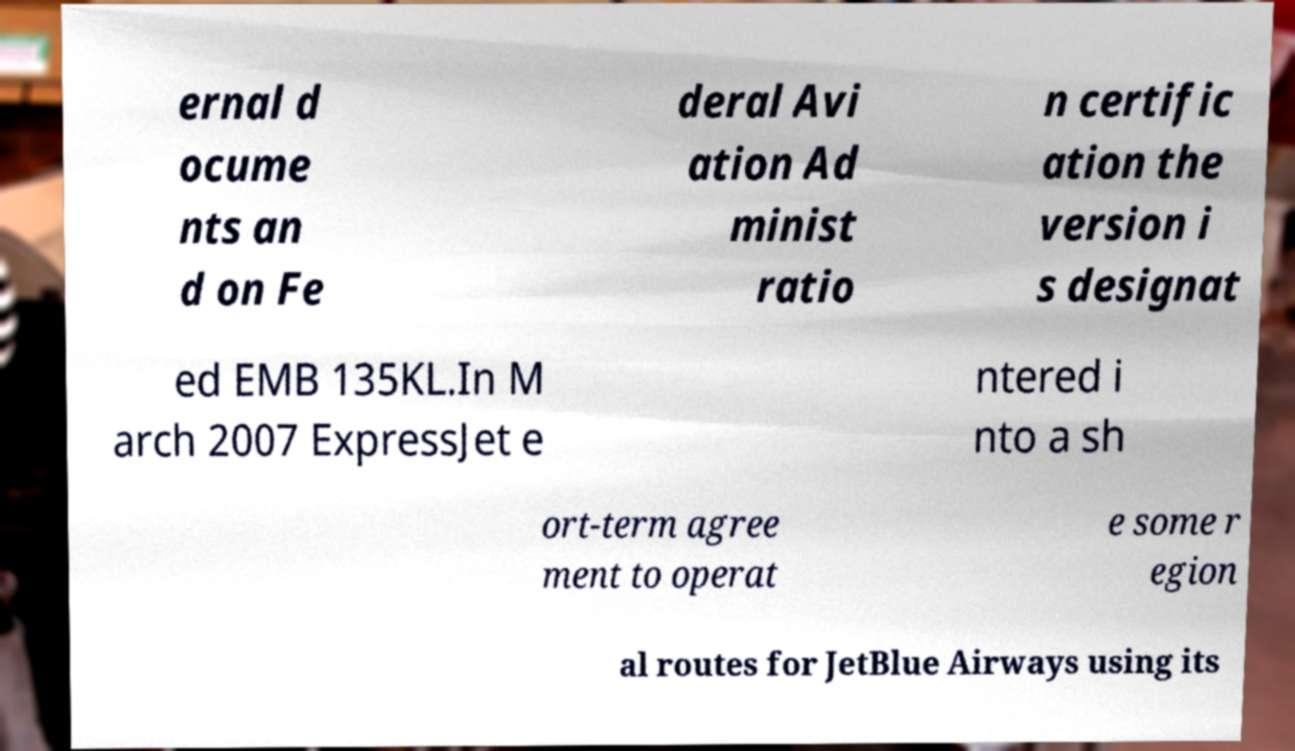I need the written content from this picture converted into text. Can you do that? ernal d ocume nts an d on Fe deral Avi ation Ad minist ratio n certific ation the version i s designat ed EMB 135KL.In M arch 2007 ExpressJet e ntered i nto a sh ort-term agree ment to operat e some r egion al routes for JetBlue Airways using its 